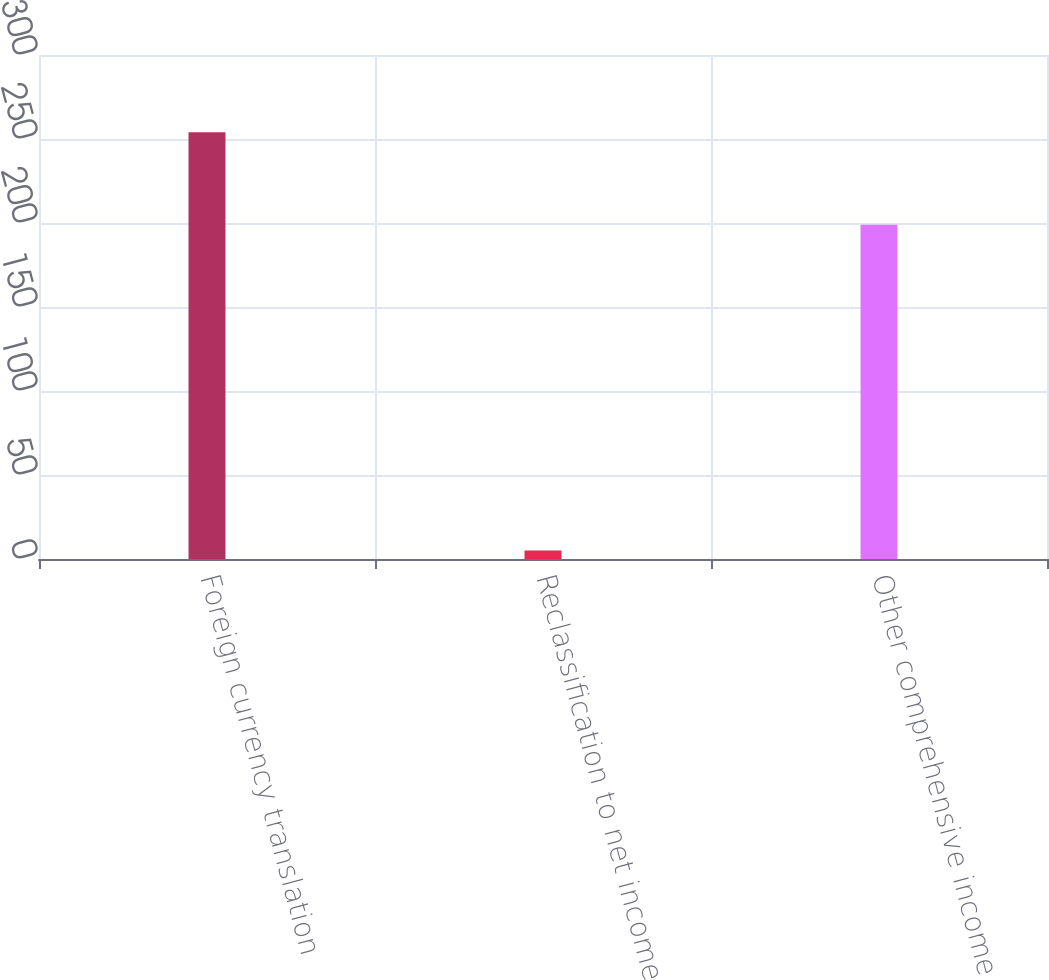Convert chart. <chart><loc_0><loc_0><loc_500><loc_500><bar_chart><fcel>Foreign currency translation<fcel>Reclassification to net income<fcel>Other comprehensive income<nl><fcel>254<fcel>5<fcel>199<nl></chart> 